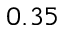Convert formula to latex. <formula><loc_0><loc_0><loc_500><loc_500>0 . 3 5</formula> 